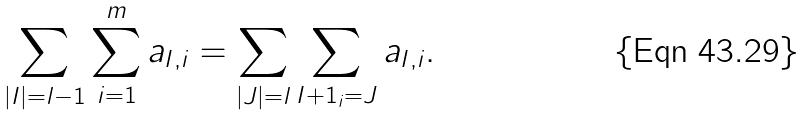<formula> <loc_0><loc_0><loc_500><loc_500>\sum _ { | I | = l - 1 } \sum _ { i = 1 } ^ { m } a _ { I , i } = \sum _ { | J | = l } \sum _ { I + 1 _ { i } = J } a _ { I , i } .</formula> 